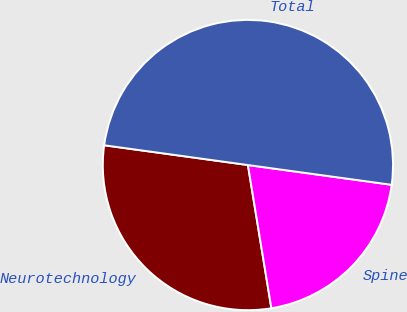<chart> <loc_0><loc_0><loc_500><loc_500><pie_chart><fcel>Neurotechnology<fcel>Spine<fcel>Total<nl><fcel>29.76%<fcel>20.24%<fcel>50.0%<nl></chart> 